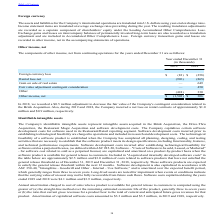According to Par Technology's financial document, What was the adjustment recorded to decrease the fair value of the Company's contingent consideration related to the Brink Acquisition in 2018? According to the financial document, $0.5 million. The relevant text states: "In 2018, we recorded a $0.5 million adjustment to decrease the fair value of the Company's contingent consideration related to the Brink..." Also, How much was the net loss on rental contracts during 2019? approximately $1.0 million. The document states: "ompany incurred a net loss on rental contracts of approximately $1.0 million and $0.9 million, respectively...." Also, What is the Foreign currency loss in 2019 and 2018 respectively? The document shows two values: $(83) and $(258) (in thousands). From the document: "Foreign currency loss $ (83) $ (258) Foreign currency loss $ (83) $ (258)..." Also, can you calculate: What is the change in Foreign currency loss between December 31, 2018 and 2019? Based on the calculation: (83)-(258), the result is 175 (in thousands). This is based on the information: "Foreign currency loss $ (83) $ (258) Foreign currency loss $ (83) $ (258)..." The key data points involved are: 258, 83. Also, can you calculate: What is the change in Rental loss-net between December 31, 2018 and 2019? Based on the calculation: (996)-(865), the result is -131 (in thousands). This is based on the information: "Rental loss-net (996) (865) Rental loss-net (996) (865)..." The key data points involved are: 865, 996. Also, can you calculate: What is the average Foreign currency loss for December 31, 2018 and 2019? To answer this question, I need to perform calculations using the financial data. The calculation is: (83+258) / 2, which equals 170.5 (in thousands). This is based on the information: "Foreign currency loss $ (83) $ (258) Foreign currency loss $ (83) $ (258)..." The key data points involved are: 258, 83. 